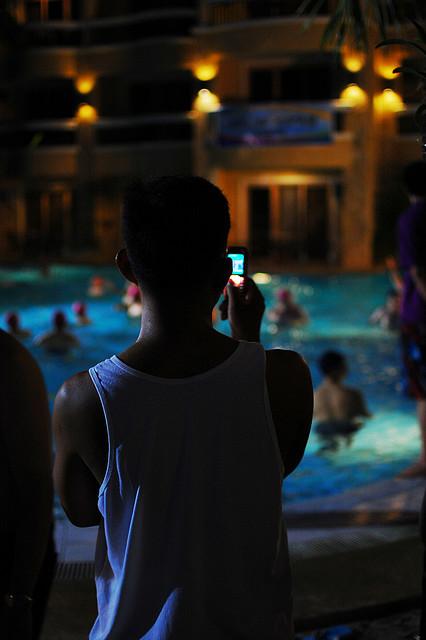Is this a parade?
Be succinct. No. How many motorcycle riders are there?
Concise answer only. 0. Is it nighttime?
Be succinct. Yes. What is the wet stuff on the ground?
Short answer required. Water. How many items does the man carry?
Give a very brief answer. 1. How many lights are in this room?
Quick response, please. 4. Is the hotel pool crowded?
Give a very brief answer. Yes. What is the boy taking a photo of?
Quick response, please. Pool. 